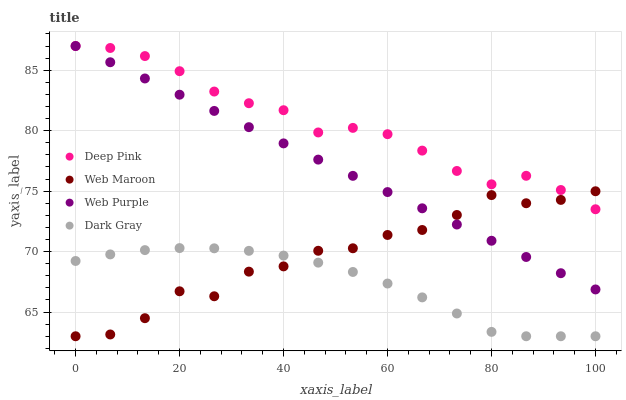Does Dark Gray have the minimum area under the curve?
Answer yes or no. Yes. Does Deep Pink have the maximum area under the curve?
Answer yes or no. Yes. Does Web Purple have the minimum area under the curve?
Answer yes or no. No. Does Web Purple have the maximum area under the curve?
Answer yes or no. No. Is Web Purple the smoothest?
Answer yes or no. Yes. Is Web Maroon the roughest?
Answer yes or no. Yes. Is Deep Pink the smoothest?
Answer yes or no. No. Is Deep Pink the roughest?
Answer yes or no. No. Does Dark Gray have the lowest value?
Answer yes or no. Yes. Does Web Purple have the lowest value?
Answer yes or no. No. Does Deep Pink have the highest value?
Answer yes or no. Yes. Does Web Maroon have the highest value?
Answer yes or no. No. Is Dark Gray less than Deep Pink?
Answer yes or no. Yes. Is Deep Pink greater than Dark Gray?
Answer yes or no. Yes. Does Web Purple intersect Web Maroon?
Answer yes or no. Yes. Is Web Purple less than Web Maroon?
Answer yes or no. No. Is Web Purple greater than Web Maroon?
Answer yes or no. No. Does Dark Gray intersect Deep Pink?
Answer yes or no. No. 